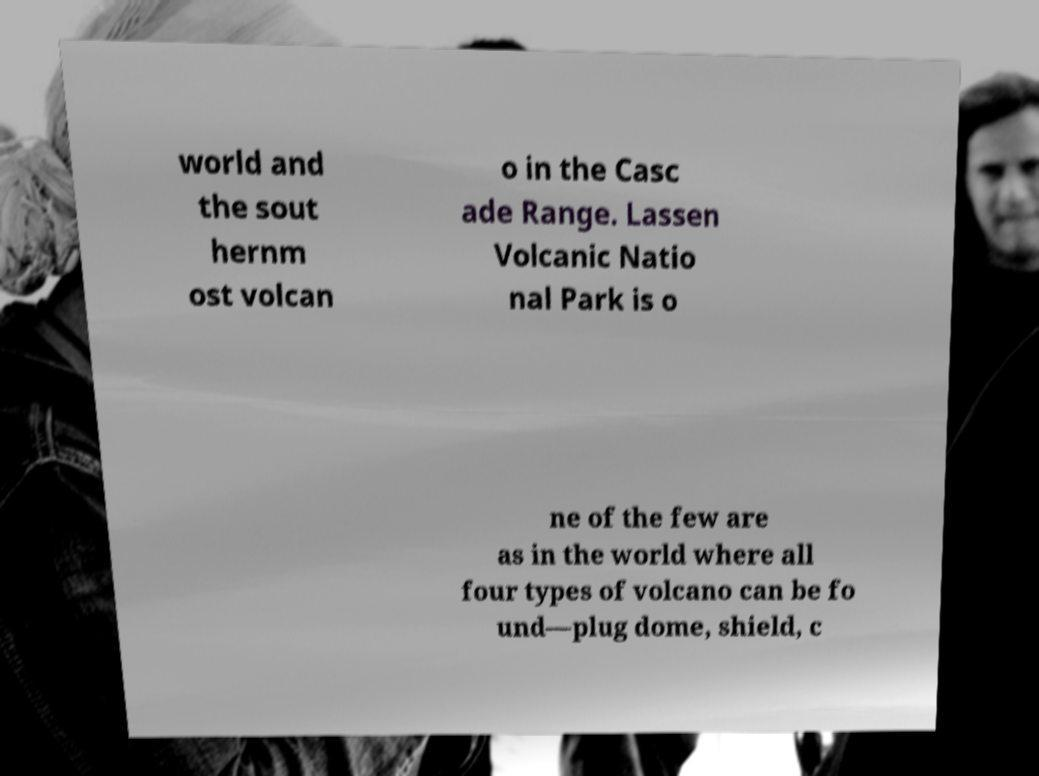Please read and relay the text visible in this image. What does it say? world and the sout hernm ost volcan o in the Casc ade Range. Lassen Volcanic Natio nal Park is o ne of the few are as in the world where all four types of volcano can be fo und—plug dome, shield, c 